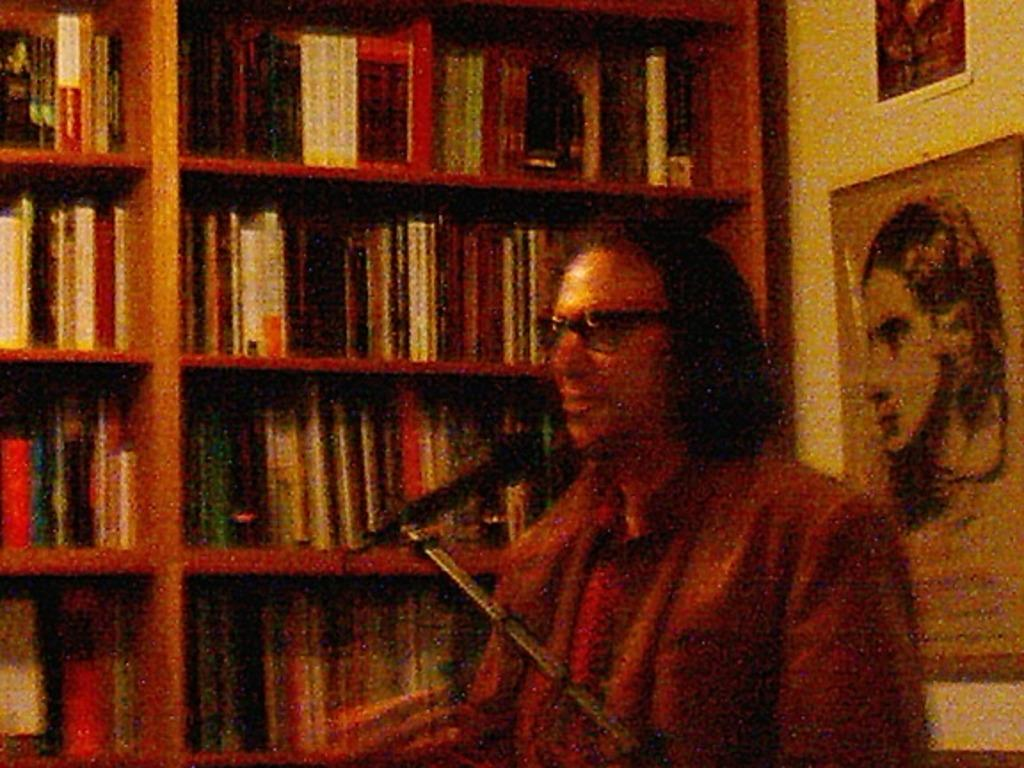<image>
Render a clear and concise summary of the photo. A man sits behind a microphone in front of a book that says Almanac on it. 